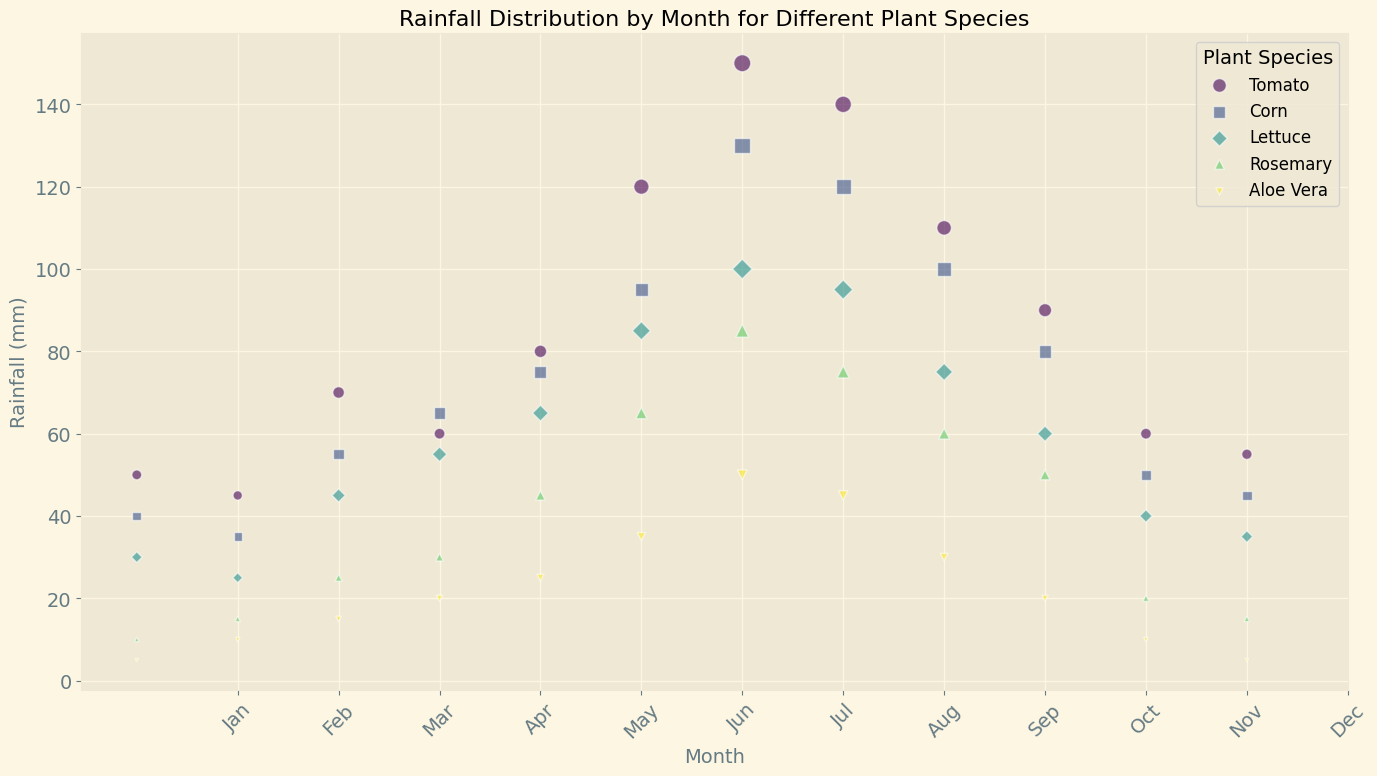Which plant species has the highest rainfall in July? To find the plant species with the highest rainfall in July, locate the month "July" and compare the bubble sizes for each species. The largest bubble size corresponds to the highest rainfall.
Answer: Tomato Which month has the lowest rainfall for Rosemary? To find the month with the lowest rainfall for Rosemary, identify the smallest bubble size in the series represented by Rosemary. The smallest bubble indicates the month with the lowest rainfall.
Answer: January Compare the rainfall of Tomato and Corn in June. Which one receives more rainfall? Locate the month "June" for both Tomato and Corn. Compare their respective bubble sizes. The larger bubble size indicates higher rainfall.
Answer: Tomato Between Lettuce and Aloe Vera, which plant species has higher overall rainfall in March? Locate the month "March" for both Lettuce and Aloe Vera. Compare the bubble sizes for these species. The larger bubble size indicates higher rainfall.
Answer: Lettuce Which month sees the maximum rainfall for Aloe Vera? To determine the month with maximum rainfall for Aloe Vera, identify the largest bubble in Aloe Vera's series. The month corresponding to this bubble is the one with maximum rainfall.
Answer: July How does the average rainfall of Rosemary from June to August compare to that of Tomato in the same period? Calculate the average rainfall for Rosemary and Tomato from June to August. For Rosemary: (65 + 85 + 75)/3 = 75 mm. For Tomato: (120 + 150 + 140)/3 = 136.67 mm. Compare the averages to see which one is higher.
Answer: Tomato has higher average rainfall Which plant species has the smallest bubble size overall, and in which month does it occur? Identify the smallest bubble size among all species and then locate the corresponding month for that species.
Answer: Aloe Vera in either January or December What is the difference in rainfall between Corn and Lettuce in October? Locate the month "October" for both Corn and Lettuce. Subtract the rainfall for Lettuce from that of Corn to find the difference.
Answer: 20 mm In which months do both Tomato and Corn have equal rainfall? Compare the bubble sizes across all months for Tomato and Corn. Identify months where both species have the same bubble size.
Answer: November 